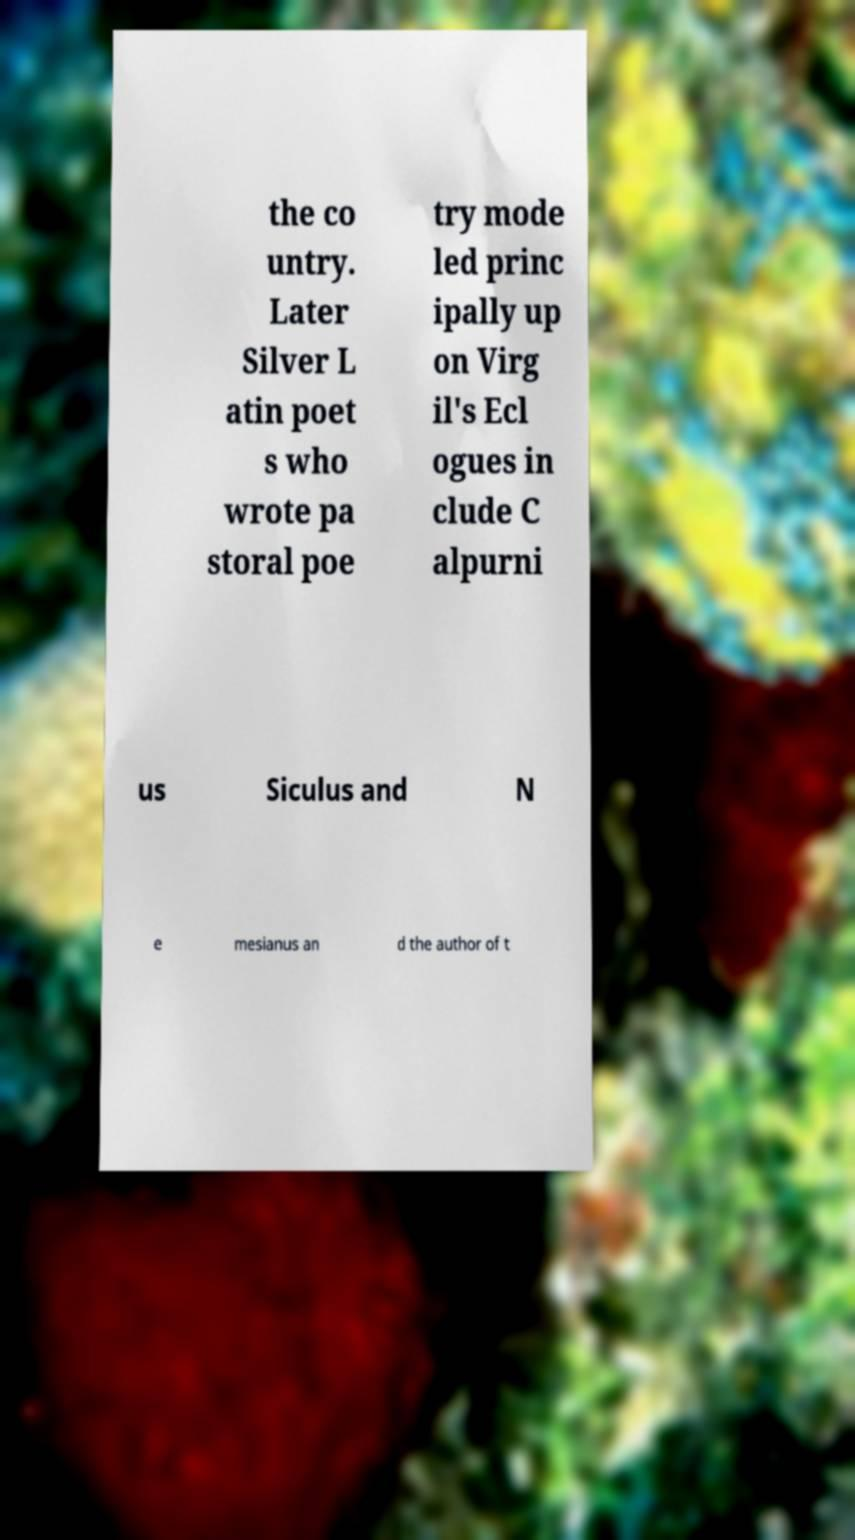For documentation purposes, I need the text within this image transcribed. Could you provide that? the co untry. Later Silver L atin poet s who wrote pa storal poe try mode led princ ipally up on Virg il's Ecl ogues in clude C alpurni us Siculus and N e mesianus an d the author of t 